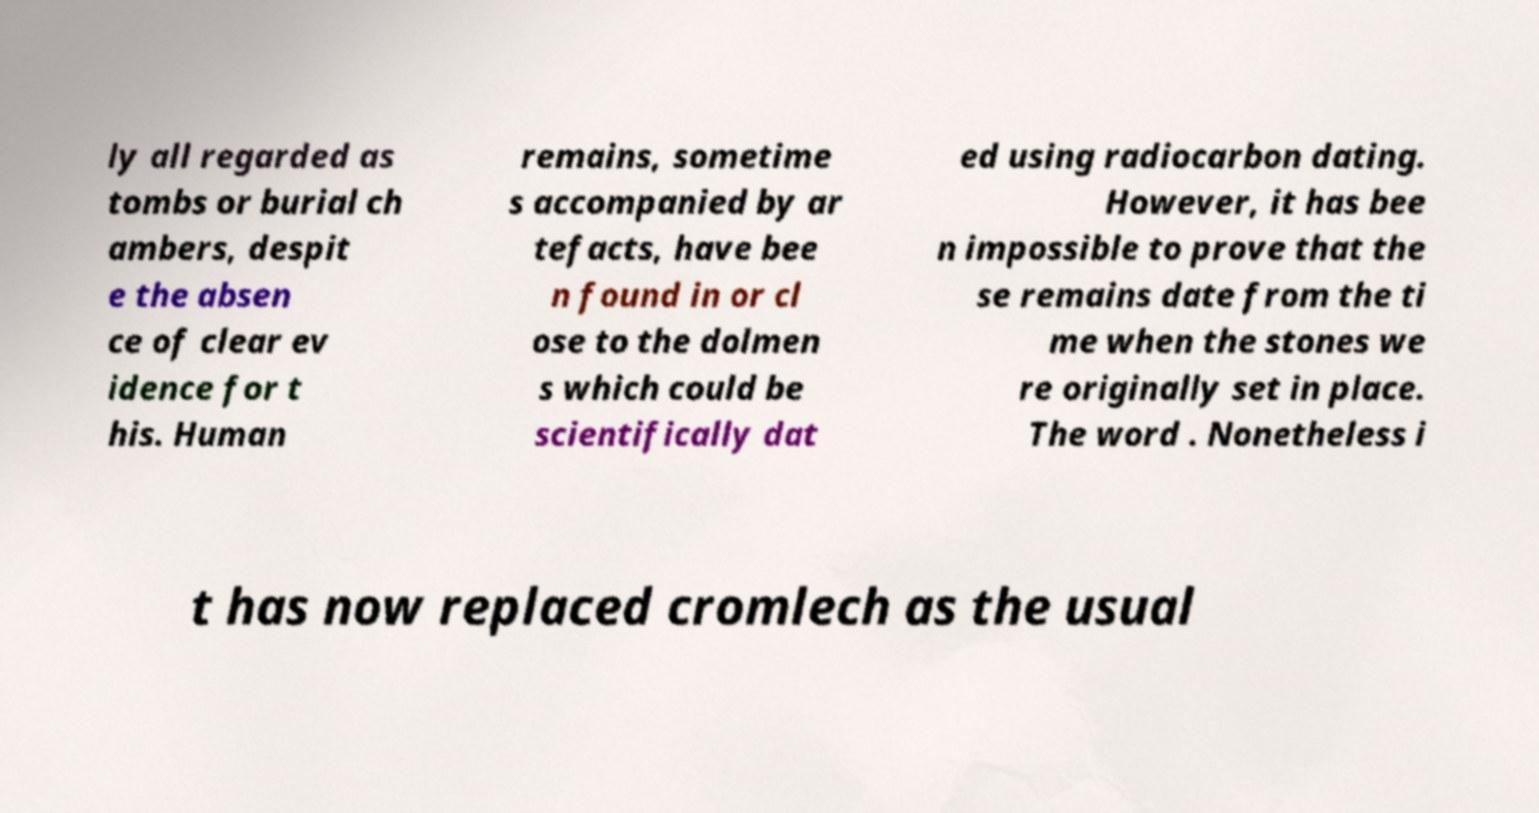Please read and relay the text visible in this image. What does it say? ly all regarded as tombs or burial ch ambers, despit e the absen ce of clear ev idence for t his. Human remains, sometime s accompanied by ar tefacts, have bee n found in or cl ose to the dolmen s which could be scientifically dat ed using radiocarbon dating. However, it has bee n impossible to prove that the se remains date from the ti me when the stones we re originally set in place. The word . Nonetheless i t has now replaced cromlech as the usual 